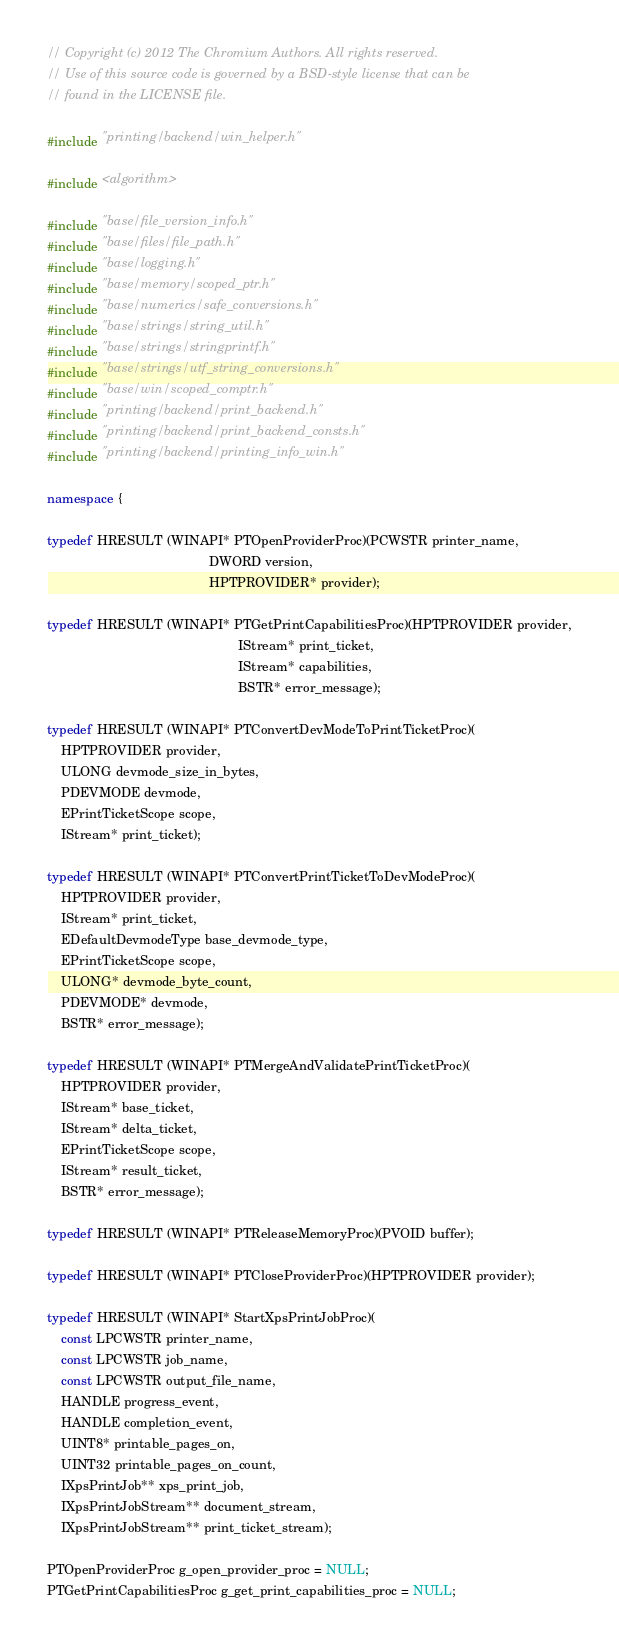<code> <loc_0><loc_0><loc_500><loc_500><_C++_>// Copyright (c) 2012 The Chromium Authors. All rights reserved.
// Use of this source code is governed by a BSD-style license that can be
// found in the LICENSE file.

#include "printing/backend/win_helper.h"

#include <algorithm>

#include "base/file_version_info.h"
#include "base/files/file_path.h"
#include "base/logging.h"
#include "base/memory/scoped_ptr.h"
#include "base/numerics/safe_conversions.h"
#include "base/strings/string_util.h"
#include "base/strings/stringprintf.h"
#include "base/strings/utf_string_conversions.h"
#include "base/win/scoped_comptr.h"
#include "printing/backend/print_backend.h"
#include "printing/backend/print_backend_consts.h"
#include "printing/backend/printing_info_win.h"

namespace {

typedef HRESULT (WINAPI* PTOpenProviderProc)(PCWSTR printer_name,
                                             DWORD version,
                                             HPTPROVIDER* provider);

typedef HRESULT (WINAPI* PTGetPrintCapabilitiesProc)(HPTPROVIDER provider,
                                                     IStream* print_ticket,
                                                     IStream* capabilities,
                                                     BSTR* error_message);

typedef HRESULT (WINAPI* PTConvertDevModeToPrintTicketProc)(
    HPTPROVIDER provider,
    ULONG devmode_size_in_bytes,
    PDEVMODE devmode,
    EPrintTicketScope scope,
    IStream* print_ticket);

typedef HRESULT (WINAPI* PTConvertPrintTicketToDevModeProc)(
    HPTPROVIDER provider,
    IStream* print_ticket,
    EDefaultDevmodeType base_devmode_type,
    EPrintTicketScope scope,
    ULONG* devmode_byte_count,
    PDEVMODE* devmode,
    BSTR* error_message);

typedef HRESULT (WINAPI* PTMergeAndValidatePrintTicketProc)(
    HPTPROVIDER provider,
    IStream* base_ticket,
    IStream* delta_ticket,
    EPrintTicketScope scope,
    IStream* result_ticket,
    BSTR* error_message);

typedef HRESULT (WINAPI* PTReleaseMemoryProc)(PVOID buffer);

typedef HRESULT (WINAPI* PTCloseProviderProc)(HPTPROVIDER provider);

typedef HRESULT (WINAPI* StartXpsPrintJobProc)(
    const LPCWSTR printer_name,
    const LPCWSTR job_name,
    const LPCWSTR output_file_name,
    HANDLE progress_event,
    HANDLE completion_event,
    UINT8* printable_pages_on,
    UINT32 printable_pages_on_count,
    IXpsPrintJob** xps_print_job,
    IXpsPrintJobStream** document_stream,
    IXpsPrintJobStream** print_ticket_stream);

PTOpenProviderProc g_open_provider_proc = NULL;
PTGetPrintCapabilitiesProc g_get_print_capabilities_proc = NULL;</code> 